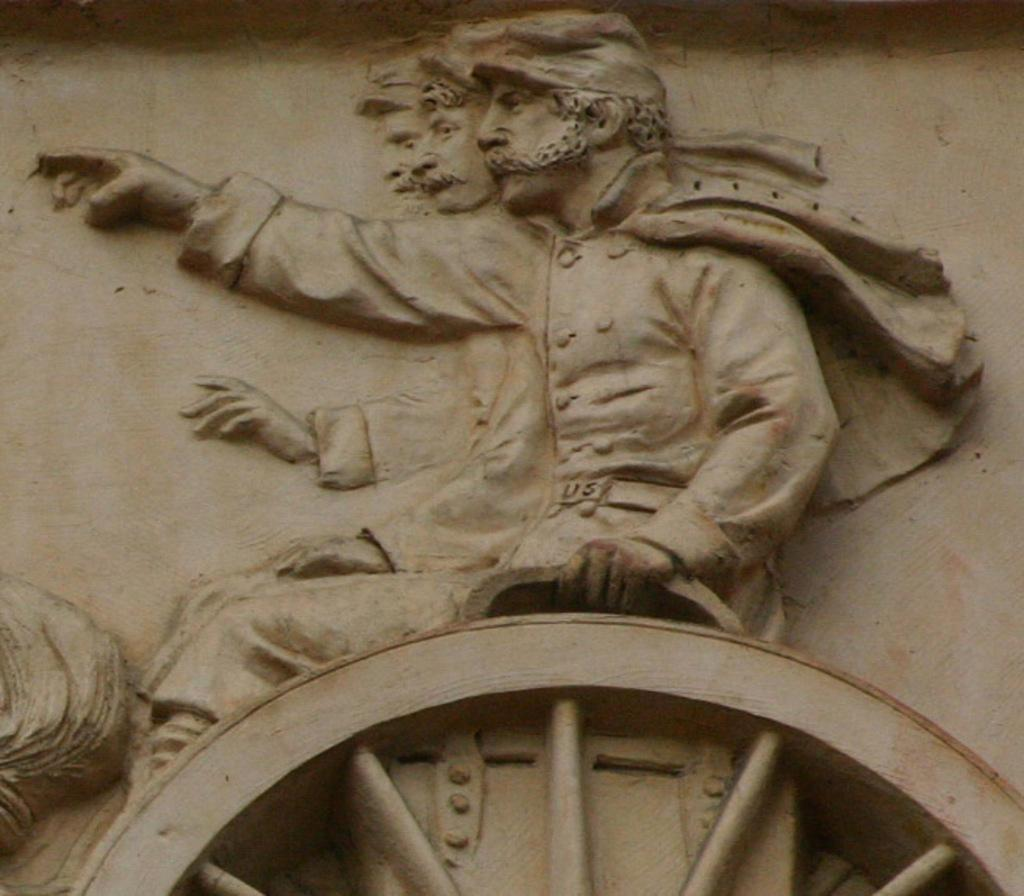What is the main subject of the image? The main subject of the image is a stone carving. What does the stone carving depict? The stone carving depicts people. Are there any other elements in the stone carving besides the people? Yes, the stone carving includes a wheel. Where is the stone carving located? The stone carving is on a wall. How does the locket on the wall open in the image? There is no locket present in the image; it features a stone carving on a wall. 